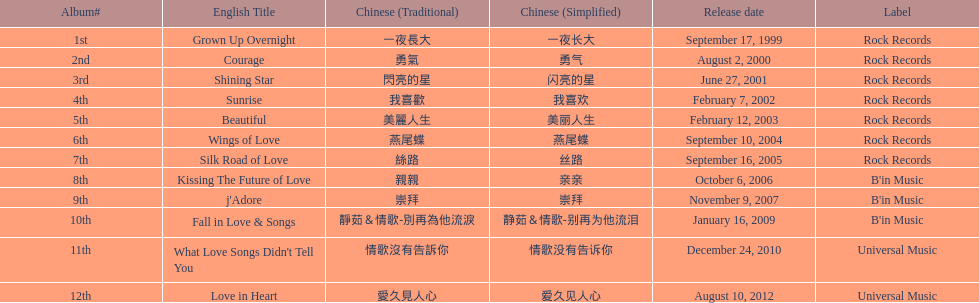Which was the sole album to be launched by b'in music in an even-numbered year? Kissing The Future of Love. 